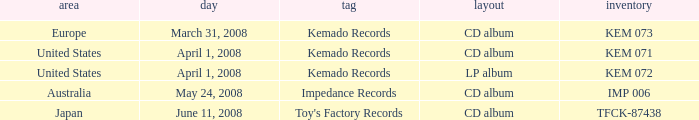Which Format has a Date of may 24, 2008? CD album. 